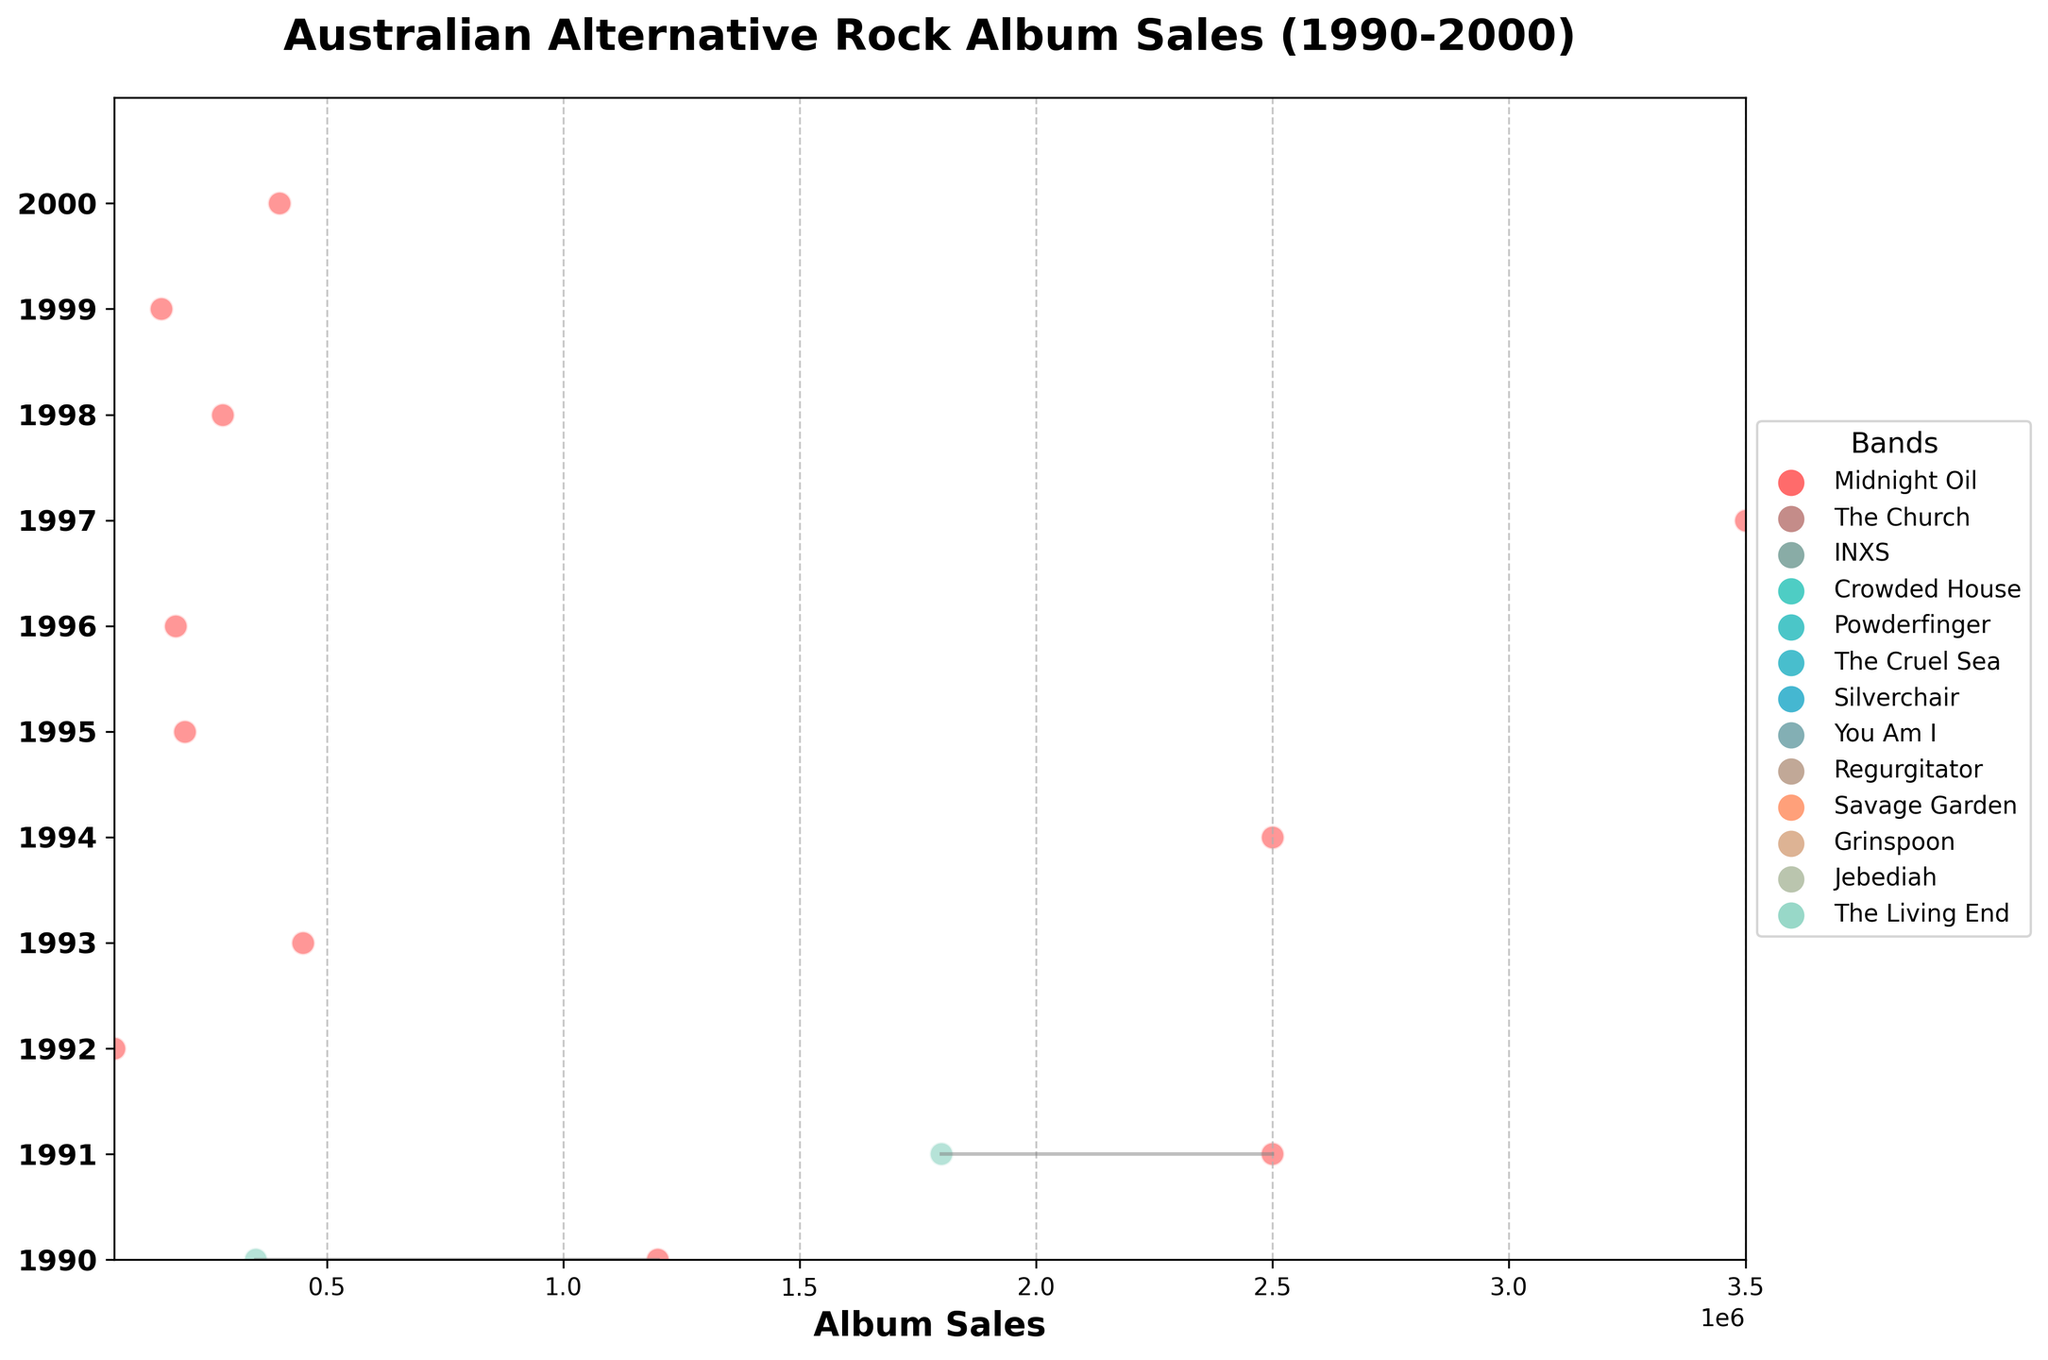What is the title of the plot? The title of the plot is displayed at the top and reads "Australian Alternative Rock Album Sales (1990-2000)."
Answer: Australian Alternative Rock Album Sales (1990-2000) How are the bands represented in the legend? Each band is represented by a colored scatter with a label next to it in the legend, which is positioned outside the plot on the right.
Answer: Colored scatter points with labels Which band has the highest album sales, and in what year did they achieve this? The highest album sales occur in 1997, and the band responsible is Savage Garden, as indicated by the highest point on the ridgeline plot for that year.
Answer: Savage Garden, 1997 Which year features the most bands releasing albums? By counting the number of scatter points on each horizontal level, 1990 and 1991 each have two bands represented, the most of any year.
Answer: 1990 and 1991 Compare the album sales of INXS's "X" with Midnight Oil's "Blue Sky Mining." Which one sold more and by how much? INXS's "X" sold 2,500,000 copies in 1991, and Midnight Oil's "Blue Sky Mining" sold 1,200,000 copies in 1990. The difference in sales is 2,500,000 - 1,200,000 = 1,300,000.
Answer: INXS's "X" sold 1,300,000 more copies What is the range of album sales for the year 1994? The year 1994 features only one album, "Frogstomp" by Silverchair, which sold 2,500,000 copies, so the range is from 2,500,000 to 2,500,000.
Answer: 2,500,000 to 2,500,000 Which band released albums in the latest year on the plot, and what is their sales figure? The latest year on the plot is 2000, and the band that released an album in that year is The Living End with "Roll On," which sold 400,000 copies.
Answer: The Living End, 400,000 What's the average album sales for the band Grinspoon? Grinspoon has one entry in 1998, "Guide to Better Living," which sold 280,000 copies. Since it's the only entry, the average sales equal 280,000.
Answer: 280,000 Is there a trend in album sales over time for these bands? Observing the ridgeline, initially, there is a relatively high variance in sales with some peaks in the early 90s and mid-90s, leading to a high peak in 1997 (Savage Garden). Sales then generally decline towards 2000.
Answer: Generally shows high variance and peaks then declines Identify the lowest album sales and the band associated with it. The lowest album sales are for Powderfinger’s "Parables for Wooden Ears," released in 1992, with only 50,000 copies sold.
Answer: Powderfinger, 50,000 